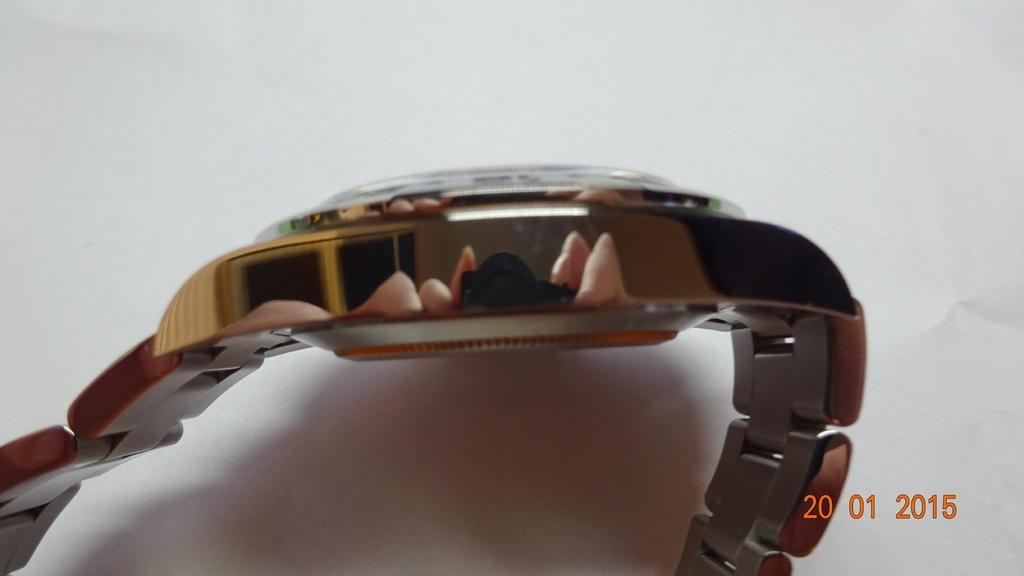Please provide a concise description of this image. In this picture there is a golden watch placed on the white paper. On the bottom right side of the image there is a small date mentioned on it. 